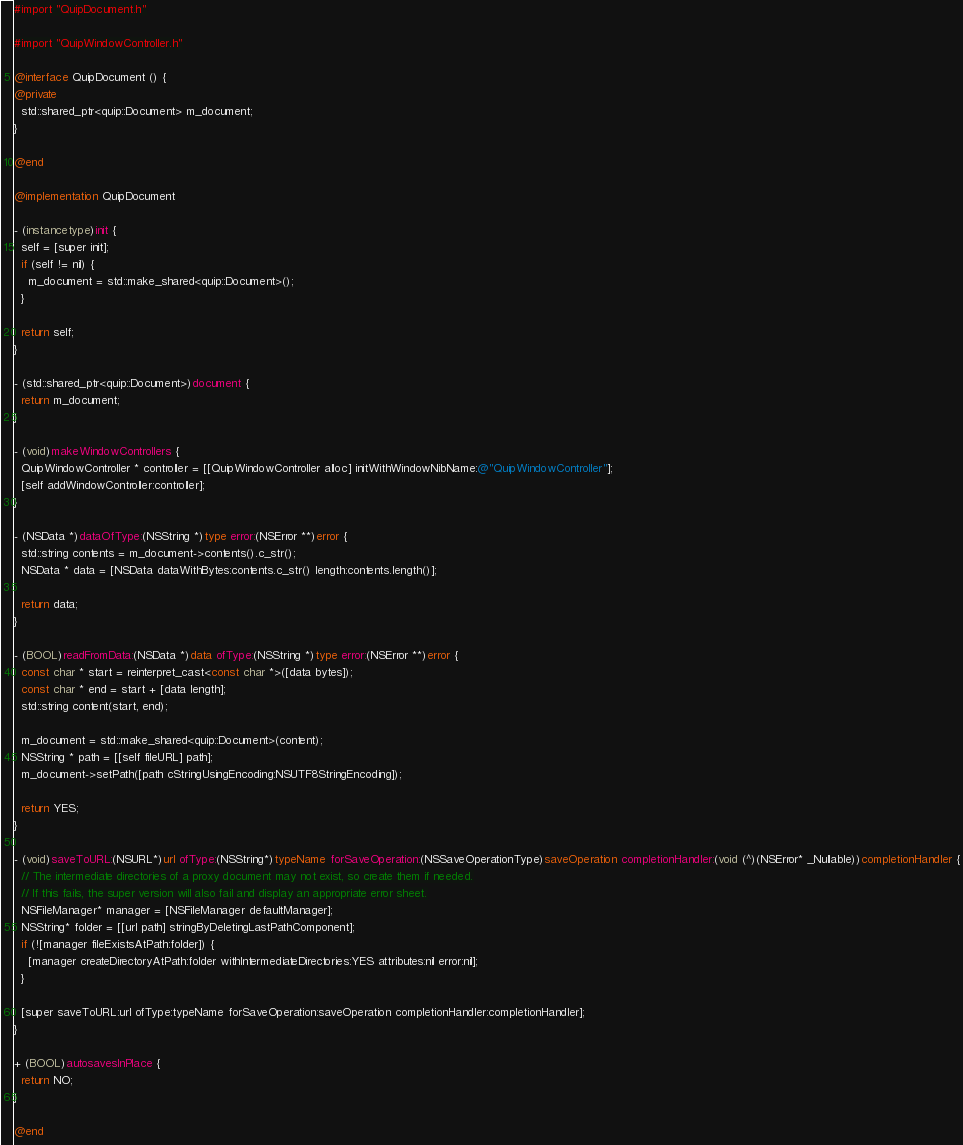<code> <loc_0><loc_0><loc_500><loc_500><_ObjectiveC_>#import "QuipDocument.h"

#import "QuipWindowController.h"

@interface QuipDocument () {
@private
  std::shared_ptr<quip::Document> m_document;
}

@end

@implementation QuipDocument

- (instancetype)init {
  self = [super init];
  if (self != nil) {
    m_document = std::make_shared<quip::Document>();
  }
  
  return self;
}

- (std::shared_ptr<quip::Document>)document {
  return m_document;
}

- (void)makeWindowControllers {
  QuipWindowController * controller = [[QuipWindowController alloc] initWithWindowNibName:@"QuipWindowController"];
  [self addWindowController:controller];
}

- (NSData *)dataOfType:(NSString *)type error:(NSError **)error {
  std::string contents = m_document->contents().c_str();
  NSData * data = [NSData dataWithBytes:contents.c_str() length:contents.length()];

  return data;
}

- (BOOL)readFromData:(NSData *)data ofType:(NSString *)type error:(NSError **)error {
  const char * start = reinterpret_cast<const char *>([data bytes]);
  const char * end = start + [data length];
  std::string content(start, end);
  
  m_document = std::make_shared<quip::Document>(content);
  NSString * path = [[self fileURL] path];
  m_document->setPath([path cStringUsingEncoding:NSUTF8StringEncoding]);

  return YES;
}

- (void)saveToURL:(NSURL*)url ofType:(NSString*)typeName forSaveOperation:(NSSaveOperationType)saveOperation completionHandler:(void (^)(NSError* _Nullable))completionHandler {
  // The intermediate directories of a proxy document may not exist, so create them if needed.
  // If this fails, the super version will also fail and display an appropriate error sheet.
  NSFileManager* manager = [NSFileManager defaultManager];
  NSString* folder = [[url path] stringByDeletingLastPathComponent];
  if (![manager fileExistsAtPath:folder]) {
    [manager createDirectoryAtPath:folder withIntermediateDirectories:YES attributes:nil error:nil];
  }

  [super saveToURL:url ofType:typeName forSaveOperation:saveOperation completionHandler:completionHandler];
}

+ (BOOL)autosavesInPlace {
  return NO;
}

@end
</code> 